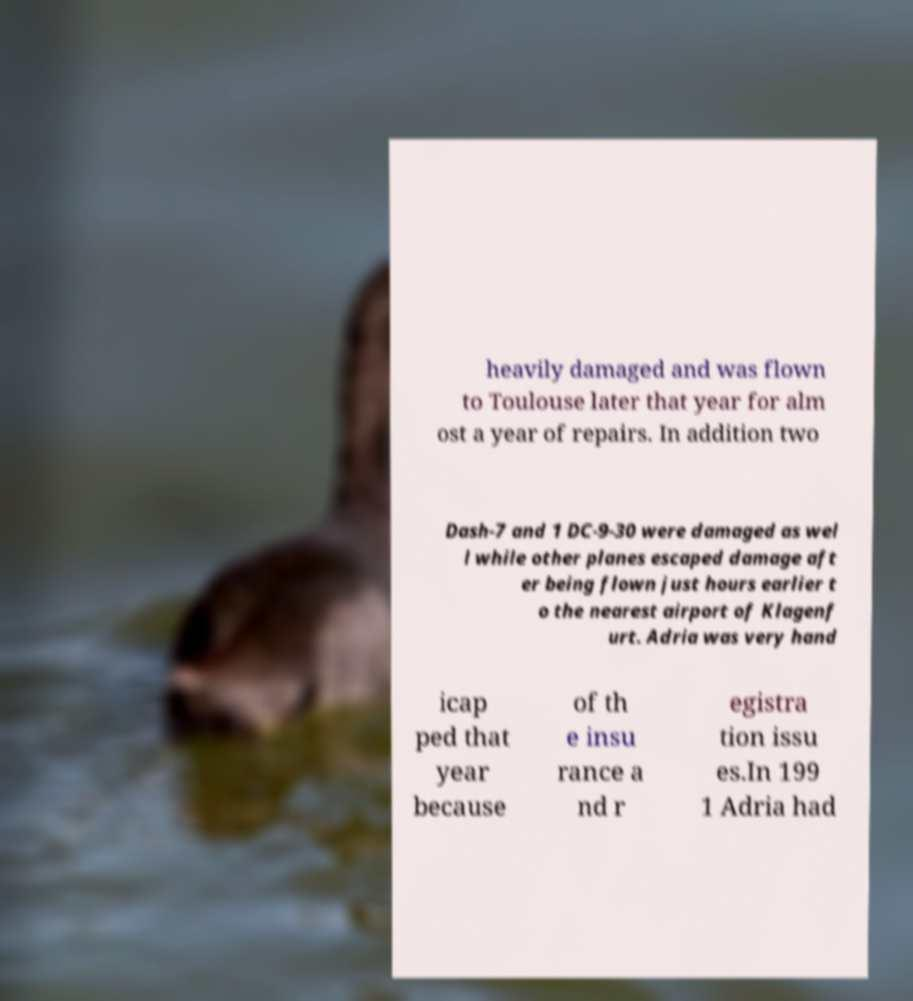For documentation purposes, I need the text within this image transcribed. Could you provide that? heavily damaged and was flown to Toulouse later that year for alm ost a year of repairs. In addition two Dash-7 and 1 DC-9-30 were damaged as wel l while other planes escaped damage aft er being flown just hours earlier t o the nearest airport of Klagenf urt. Adria was very hand icap ped that year because of th e insu rance a nd r egistra tion issu es.In 199 1 Adria had 